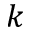<formula> <loc_0><loc_0><loc_500><loc_500>k</formula> 